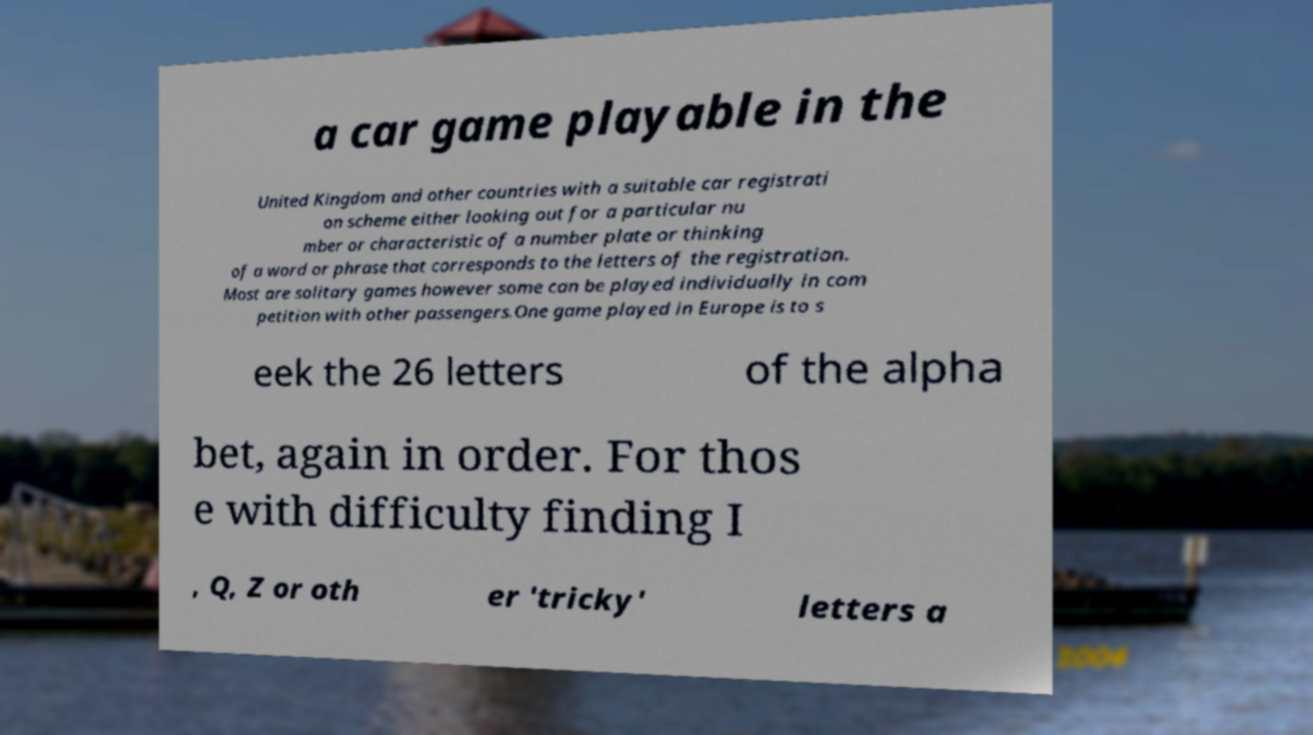Please identify and transcribe the text found in this image. a car game playable in the United Kingdom and other countries with a suitable car registrati on scheme either looking out for a particular nu mber or characteristic of a number plate or thinking of a word or phrase that corresponds to the letters of the registration. Most are solitary games however some can be played individually in com petition with other passengers.One game played in Europe is to s eek the 26 letters of the alpha bet, again in order. For thos e with difficulty finding I , Q, Z or oth er 'tricky' letters a 